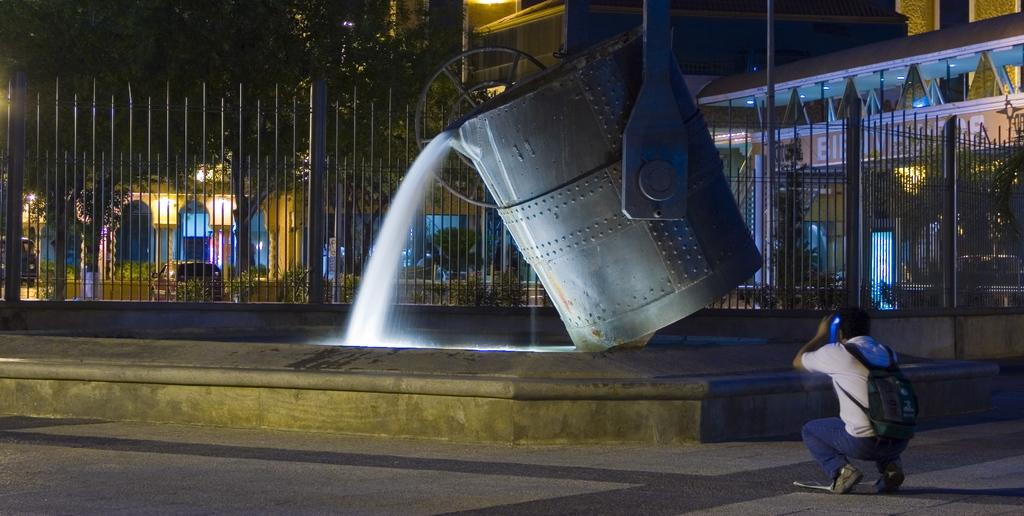What is the main subject in the image? There is a fountain in the image. What is the person in the image doing? A person is capturing a picture in the image. What can be seen in the background of the image? There are trees and buildings in the background of the image. What type of rifle is the person using to take the picture in the image? There is no rifle present in the image; the person is using a camera or a smartphone to capture the picture. 